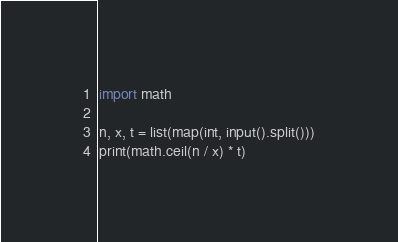Convert code to text. <code><loc_0><loc_0><loc_500><loc_500><_Python_>import math

n, x, t = list(map(int, input().split()))
print(math.ceil(n / x) * t)
</code> 